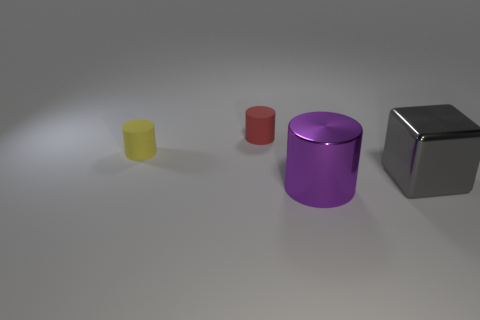What material is the object that is behind the big purple thing and in front of the yellow thing? The object located behind the large purple cylinder and in front of the yellow cylinder appears to be made of metal, likely stainless steel, given its reflective silver surface and the way it interacts with light. 